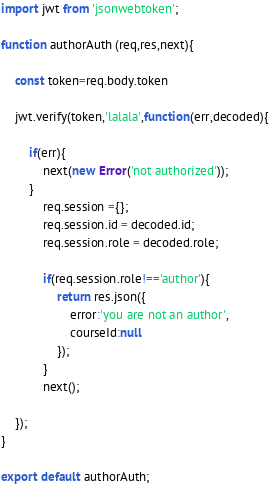<code> <loc_0><loc_0><loc_500><loc_500><_JavaScript_>import jwt from 'jsonwebtoken';

function authorAuth (req,res,next){
    
    const token=req.body.token
    
    jwt.verify(token,'lalala',function(err,decoded){

        if(err){
            next(new Error('not authorized'));
        }
            req.session ={};
            req.session.id = decoded.id;
            req.session.role = decoded.role;

            if(req.session.role!=='author'){
                return res.json({
                    error:'you are not an author',
                    courseId:null
                });
            }
            next();
    
    });
}

export default authorAuth;</code> 